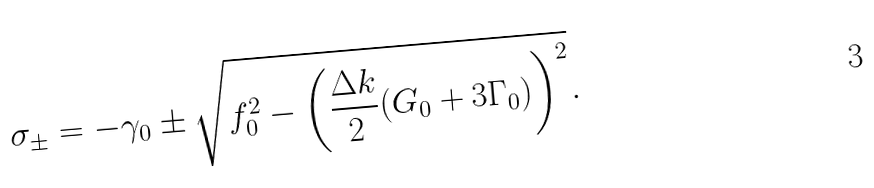<formula> <loc_0><loc_0><loc_500><loc_500>\sigma _ { \pm } = - \gamma _ { 0 } \pm \sqrt { f _ { 0 } ^ { 2 } - \left ( \frac { \Delta k } { 2 } ( G _ { 0 } + 3 \Gamma _ { 0 } ) \right ) ^ { 2 } } .</formula> 